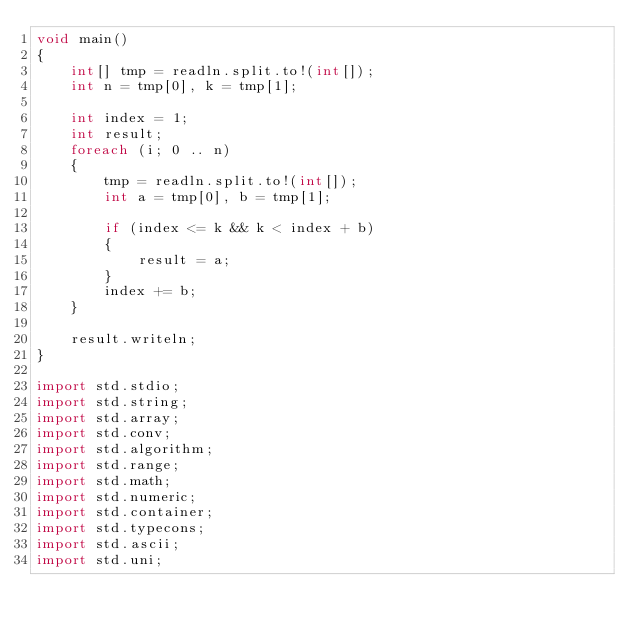<code> <loc_0><loc_0><loc_500><loc_500><_D_>void main()
{
    int[] tmp = readln.split.to!(int[]);
    int n = tmp[0], k = tmp[1];

    int index = 1;
    int result;
    foreach (i; 0 .. n)
    {
        tmp = readln.split.to!(int[]);
        int a = tmp[0], b = tmp[1];

        if (index <= k && k < index + b)
        {
            result = a;
        }
        index += b;
    }

    result.writeln;
}

import std.stdio;
import std.string;
import std.array;
import std.conv;
import std.algorithm;
import std.range;
import std.math;
import std.numeric;
import std.container;
import std.typecons;
import std.ascii;
import std.uni;</code> 